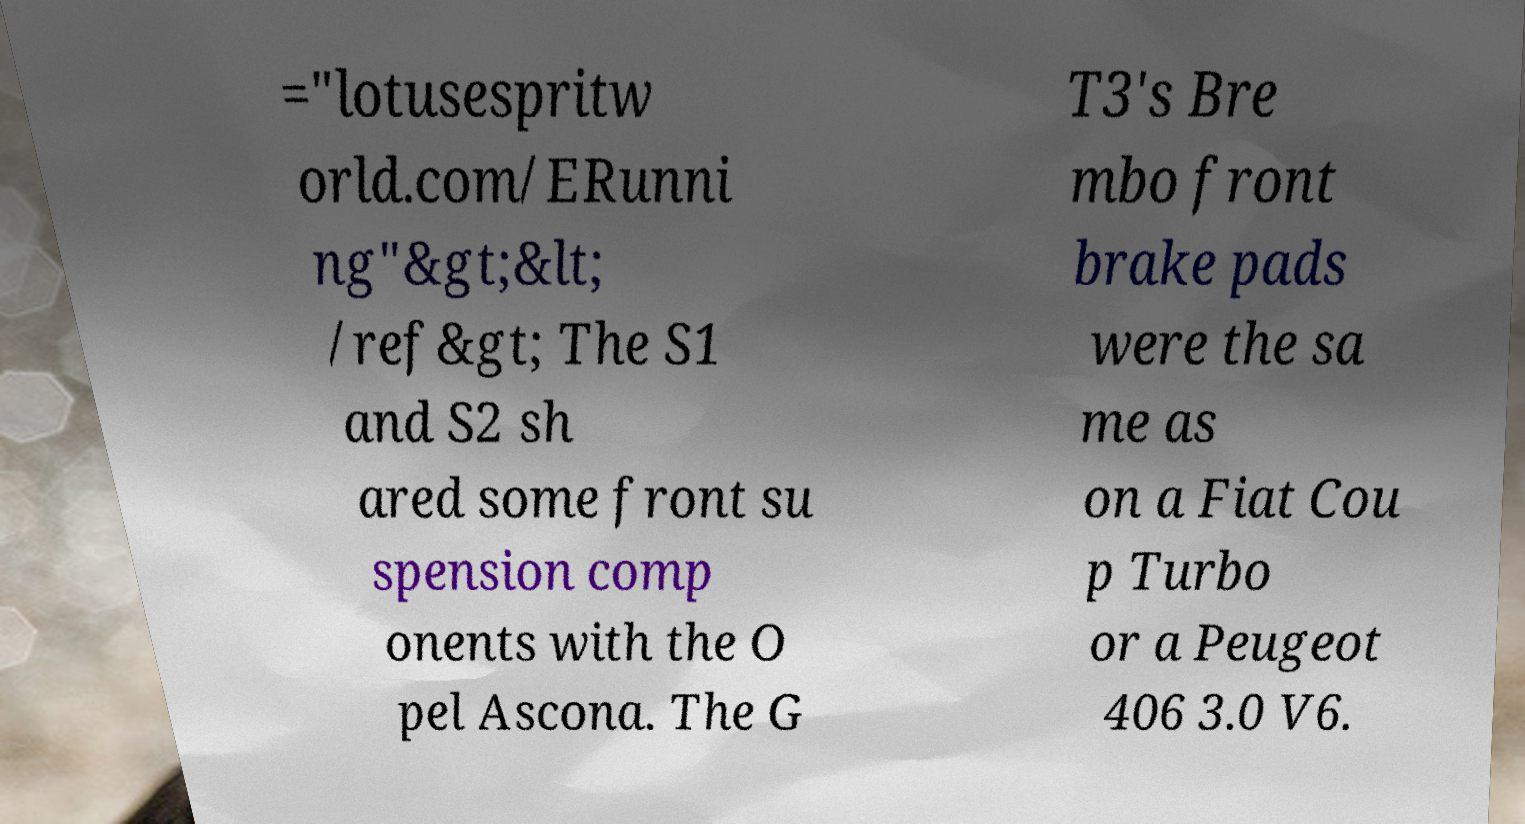Can you accurately transcribe the text from the provided image for me? ="lotusespritw orld.com/ERunni ng"&gt;&lt; /ref&gt; The S1 and S2 sh ared some front su spension comp onents with the O pel Ascona. The G T3's Bre mbo front brake pads were the sa me as on a Fiat Cou p Turbo or a Peugeot 406 3.0 V6. 